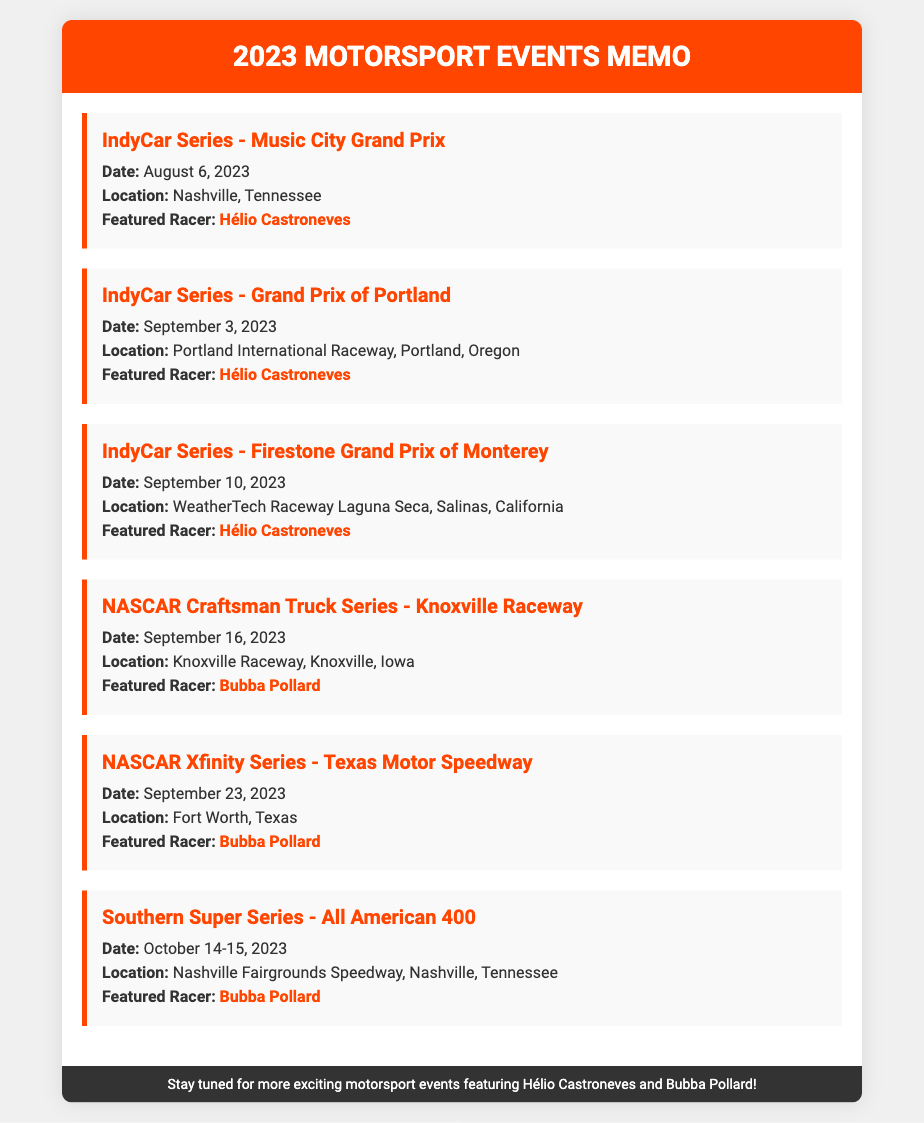what is the date of the Music City Grand Prix? The date is specified in the event information for the IndyCar Series - Music City Grand Prix.
Answer: August 6, 2023 where is the Grand Prix of Portland located? The location is listed in the event details for the IndyCar Series - Grand Prix of Portland.
Answer: Portland International Raceway, Portland, Oregon who is the featured racer in the Firestone Grand Prix of Monterey? The featured racer is mentioned in the event details for the IndyCar Series - Firestone Grand Prix of Monterey.
Answer: Hélio Castroneves how many events feature Bubba Pollard? The number of events is determined by counting the occurrences where Bubba Pollard is listed as the featured racer.
Answer: Three what type of event is the All American 400? The type of event is indicated in the event title for the Southern Super Series - All American 400.
Answer: Southern Super Series which race takes place on September 23, 2023? The race is mentioned in the event details for the NASCAR Xfinity Series that corresponds to the date.
Answer: NASCAR Xfinity Series - Texas Motor Speedway in which city is the Knoxville Raceway located? The city is given in the location details of the NASCAR Craftsman Truck Series - Knoxville Raceway.
Answer: Knoxville, Iowa what is the primary color used in the document’s header? The primary color can be identified from the style of the header section in the document.
Answer: Orange 